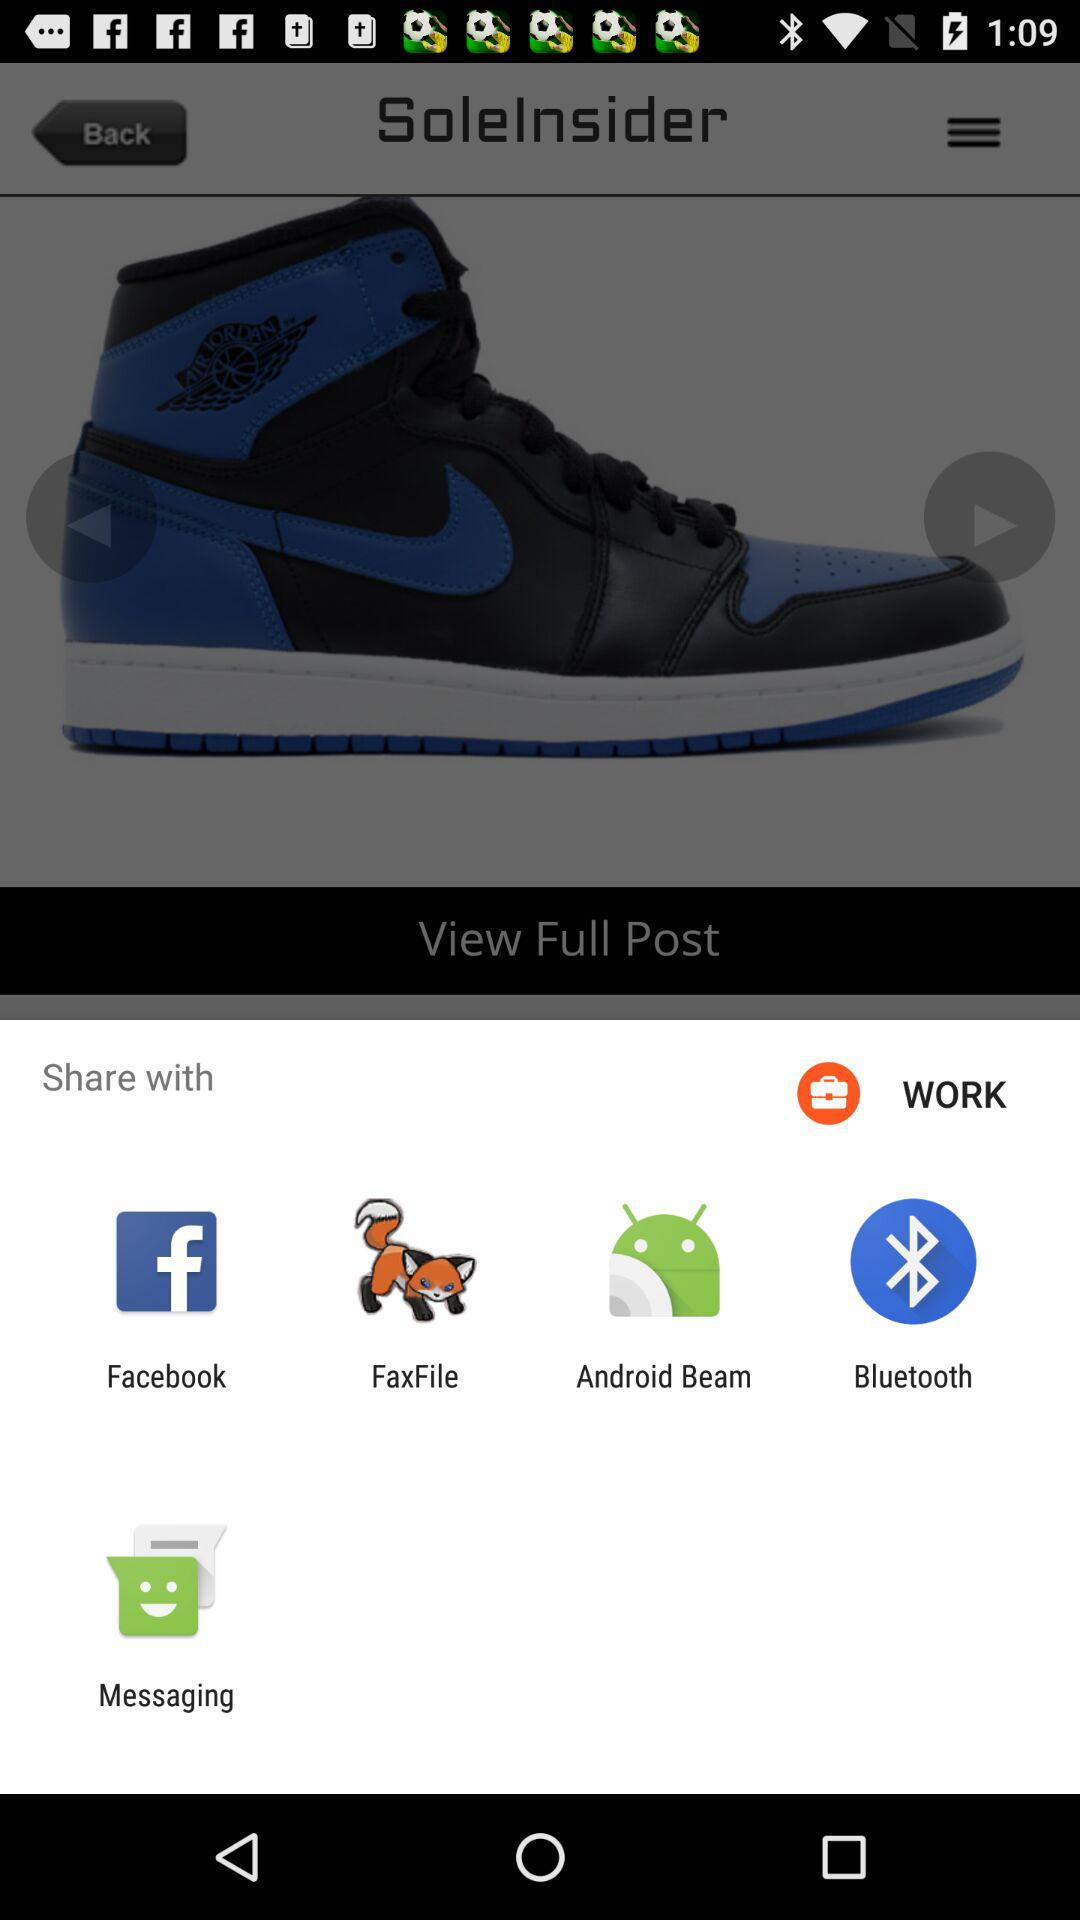What are the sharing applications with which I can share? The sharing applications with which you can share are "Facebook", "FaxFile", "Android Beam", "Bluetooth" and "Messaging". 